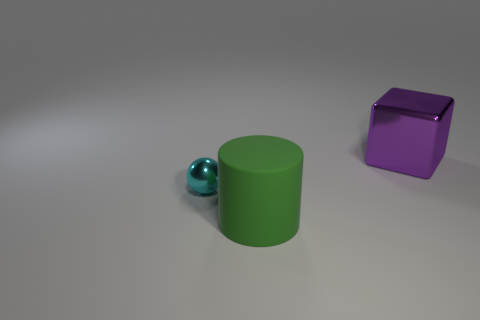Is there a object of the same color as the cylinder?
Offer a terse response. No. Are there any big rubber things that have the same shape as the cyan metallic thing?
Keep it short and to the point. No. What shape is the object that is to the right of the cyan shiny thing and behind the green cylinder?
Provide a short and direct response. Cube. What number of other green objects have the same material as the green thing?
Offer a very short reply. 0. Are there fewer rubber objects that are behind the tiny cyan ball than blue rubber cubes?
Give a very brief answer. No. There is a large thing that is on the left side of the shiny block; are there any shiny blocks on the left side of it?
Your answer should be compact. No. Are there any other things that are the same shape as the purple metallic thing?
Offer a very short reply. No. Does the rubber object have the same size as the cyan shiny ball?
Make the answer very short. No. The cylinder that is right of the metallic object on the left side of the large object behind the cyan metal thing is made of what material?
Your response must be concise. Rubber. Are there the same number of small cyan metallic balls that are behind the tiny sphere and big cylinders?
Give a very brief answer. No. 